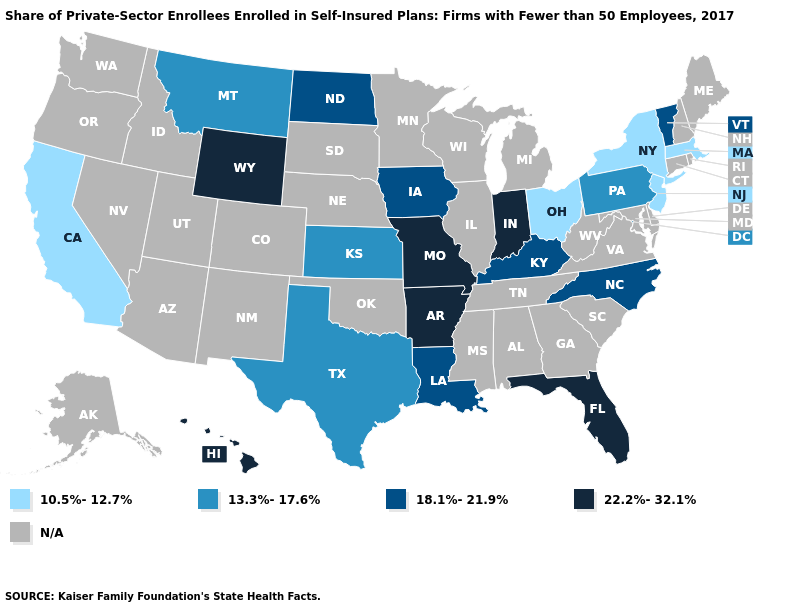What is the lowest value in the USA?
Be succinct. 10.5%-12.7%. Name the states that have a value in the range N/A?
Quick response, please. Alabama, Alaska, Arizona, Colorado, Connecticut, Delaware, Georgia, Idaho, Illinois, Maine, Maryland, Michigan, Minnesota, Mississippi, Nebraska, Nevada, New Hampshire, New Mexico, Oklahoma, Oregon, Rhode Island, South Carolina, South Dakota, Tennessee, Utah, Virginia, Washington, West Virginia, Wisconsin. What is the value of Rhode Island?
Concise answer only. N/A. Name the states that have a value in the range 10.5%-12.7%?
Keep it brief. California, Massachusetts, New Jersey, New York, Ohio. What is the value of Connecticut?
Give a very brief answer. N/A. Does the first symbol in the legend represent the smallest category?
Concise answer only. Yes. Name the states that have a value in the range 18.1%-21.9%?
Write a very short answer. Iowa, Kentucky, Louisiana, North Carolina, North Dakota, Vermont. Does North Carolina have the highest value in the USA?
Quick response, please. No. Does Ohio have the lowest value in the MidWest?
Quick response, please. Yes. What is the value of Maine?
Quick response, please. N/A. Name the states that have a value in the range 22.2%-32.1%?
Short answer required. Arkansas, Florida, Hawaii, Indiana, Missouri, Wyoming. What is the value of Georgia?
Be succinct. N/A. Does the first symbol in the legend represent the smallest category?
Quick response, please. Yes. 